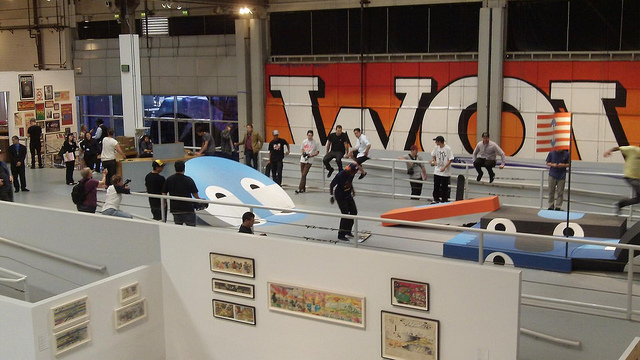Please identify all text content in this image. WOI 